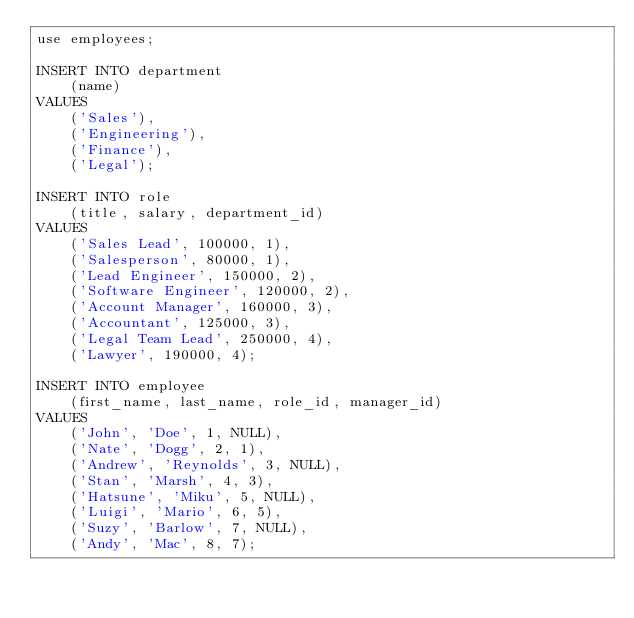Convert code to text. <code><loc_0><loc_0><loc_500><loc_500><_SQL_>use employees;

INSERT INTO department
    (name)
VALUES
    ('Sales'),
    ('Engineering'),
    ('Finance'),
    ('Legal');

INSERT INTO role
    (title, salary, department_id)
VALUES
    ('Sales Lead', 100000, 1),
    ('Salesperson', 80000, 1),
    ('Lead Engineer', 150000, 2),
    ('Software Engineer', 120000, 2),
    ('Account Manager', 160000, 3),
    ('Accountant', 125000, 3),
    ('Legal Team Lead', 250000, 4),
    ('Lawyer', 190000, 4);

INSERT INTO employee
    (first_name, last_name, role_id, manager_id)
VALUES
    ('John', 'Doe', 1, NULL),
    ('Nate', 'Dogg', 2, 1),
    ('Andrew', 'Reynolds', 3, NULL),
    ('Stan', 'Marsh', 4, 3),
    ('Hatsune', 'Miku', 5, NULL),
    ('Luigi', 'Mario', 6, 5),
    ('Suzy', 'Barlow', 7, NULL),
    ('Andy', 'Mac', 8, 7);
</code> 